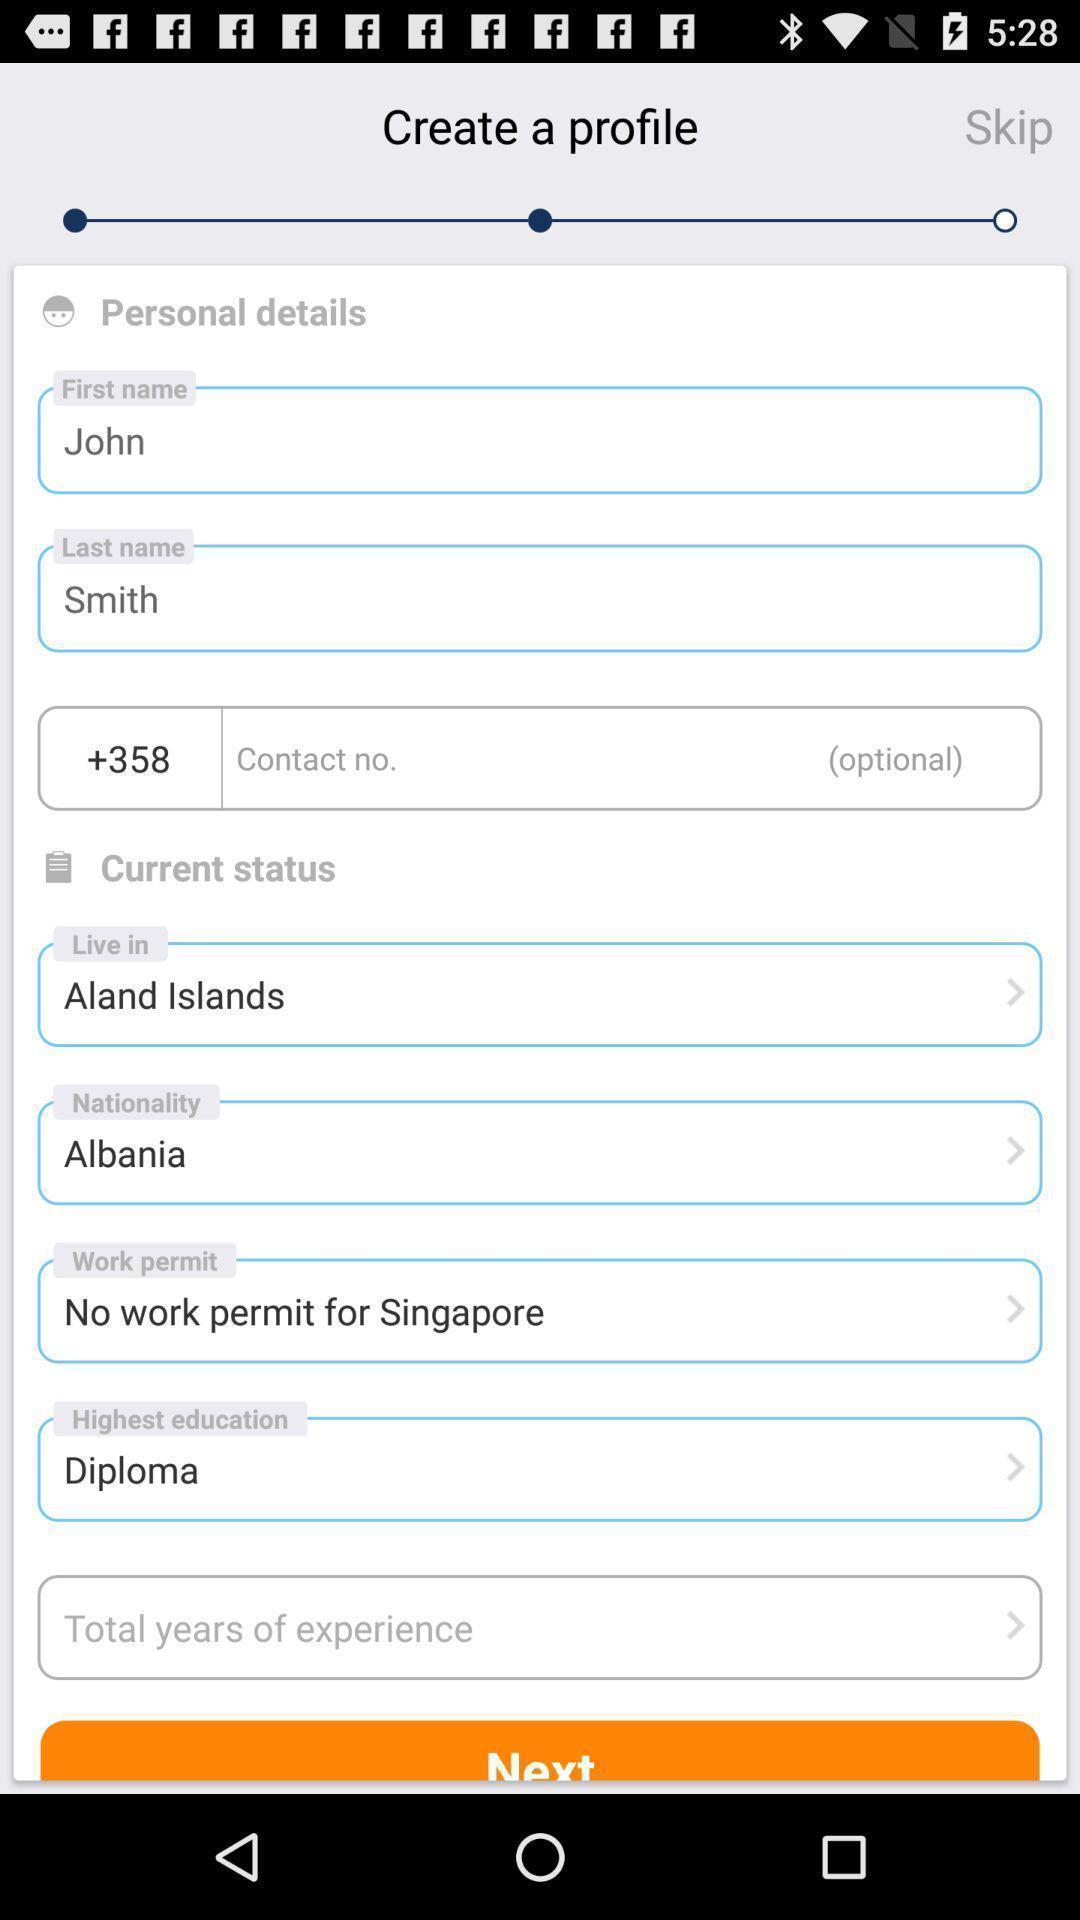What can you discern from this picture? Screen shows create profile option in a job app. 